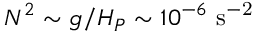<formula> <loc_0><loc_0><loc_500><loc_500>N ^ { 2 } \sim g / H _ { P } \sim 1 0 ^ { - 6 } s ^ { - 2 }</formula> 